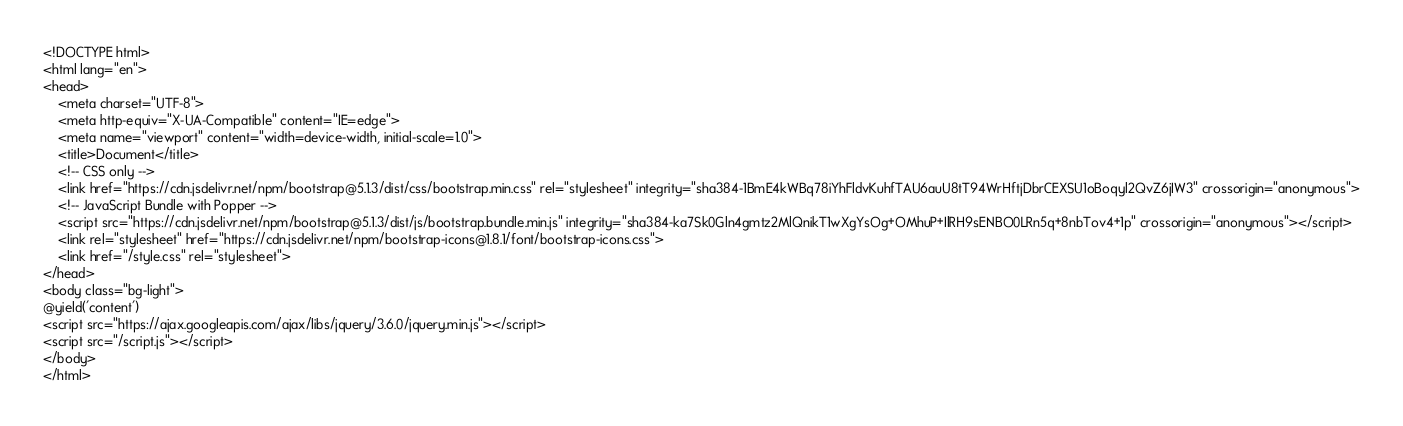<code> <loc_0><loc_0><loc_500><loc_500><_PHP_><!DOCTYPE html>
<html lang="en">
<head>
    <meta charset="UTF-8">
    <meta http-equiv="X-UA-Compatible" content="IE=edge">
    <meta name="viewport" content="width=device-width, initial-scale=1.0">
    <title>Document</title>
    <!-- CSS only -->
    <link href="https://cdn.jsdelivr.net/npm/bootstrap@5.1.3/dist/css/bootstrap.min.css" rel="stylesheet" integrity="sha384-1BmE4kWBq78iYhFldvKuhfTAU6auU8tT94WrHftjDbrCEXSU1oBoqyl2QvZ6jIW3" crossorigin="anonymous">
    <!-- JavaScript Bundle with Popper -->
    <script src="https://cdn.jsdelivr.net/npm/bootstrap@5.1.3/dist/js/bootstrap.bundle.min.js" integrity="sha384-ka7Sk0Gln4gmtz2MlQnikT1wXgYsOg+OMhuP+IlRH9sENBO0LRn5q+8nbTov4+1p" crossorigin="anonymous"></script>
    <link rel="stylesheet" href="https://cdn.jsdelivr.net/npm/bootstrap-icons@1.8.1/font/bootstrap-icons.css">
    <link href="/style.css" rel="stylesheet">
</head>
<body class="bg-light">
@yield('content')
<script src="https://ajax.googleapis.com/ajax/libs/jquery/3.6.0/jquery.min.js"></script>
<script src="/script.js"></script>
</body>
</html></code> 